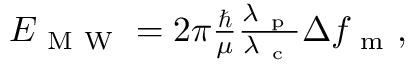<formula> <loc_0><loc_0><loc_500><loc_500>\begin{array} { r } { E _ { M W } = 2 \pi \frac { } { \mu } \frac { \lambda _ { p } } { \lambda _ { c } } \Delta { f _ { m } } , } \end{array}</formula> 